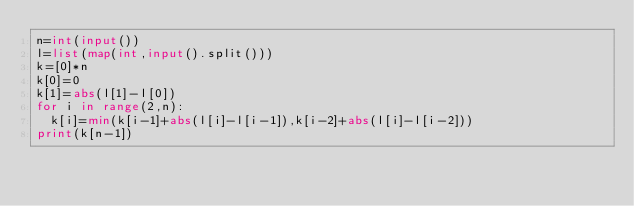Convert code to text. <code><loc_0><loc_0><loc_500><loc_500><_Python_>n=int(input())
l=list(map(int,input().split()))
k=[0]*n
k[0]=0
k[1]=abs(l[1]-l[0])
for i in range(2,n):
  k[i]=min(k[i-1]+abs(l[i]-l[i-1]),k[i-2]+abs(l[i]-l[i-2]))
print(k[n-1])</code> 